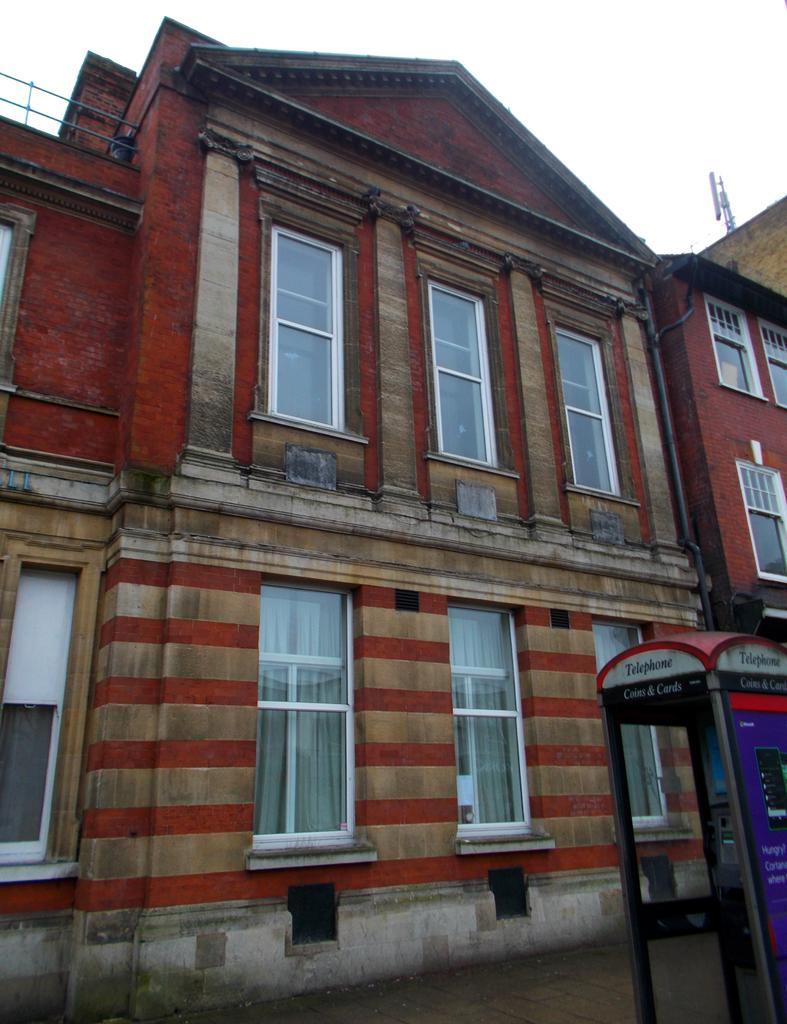What is the main structure visible in the image? There is a house in the image. What feature can be seen on the house? The house has windows. How many birds are attempting to make a profit by flying through the windows of the house in the image? There are no birds present in the image, and therefore no such activity can be observed. 